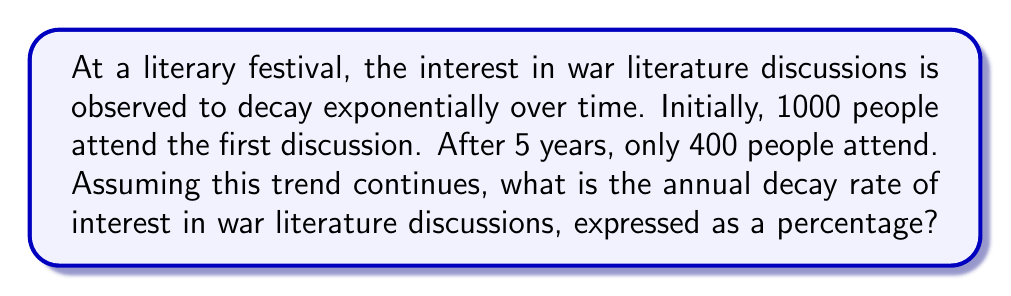Teach me how to tackle this problem. Let's approach this step-by-step using the exponential decay formula:

1) The exponential decay formula is:
   $$A(t) = A_0 * (1-r)^t$$
   Where:
   $A(t)$ is the amount at time $t$
   $A_0$ is the initial amount
   $r$ is the decay rate (as a decimal)
   $t$ is the time

2) We know:
   $A_0 = 1000$ (initial attendance)
   $A(5) = 400$ (attendance after 5 years)
   $t = 5$ (years)

3) Let's plug these into our formula:
   $$400 = 1000 * (1-r)^5$$

4) Divide both sides by 1000:
   $$0.4 = (1-r)^5$$

5) Take the 5th root of both sides:
   $$\sqrt[5]{0.4} = 1-r$$

6) Solve for $r$:
   $$r = 1 - \sqrt[5]{0.4}$$

7) Calculate:
   $$r = 1 - 0.83255...$$
   $$r = 0.16745...$$

8) Convert to a percentage:
   $$r * 100 = 16.745...$$

Therefore, the annual decay rate is approximately 16.75%.
Answer: 16.75% 